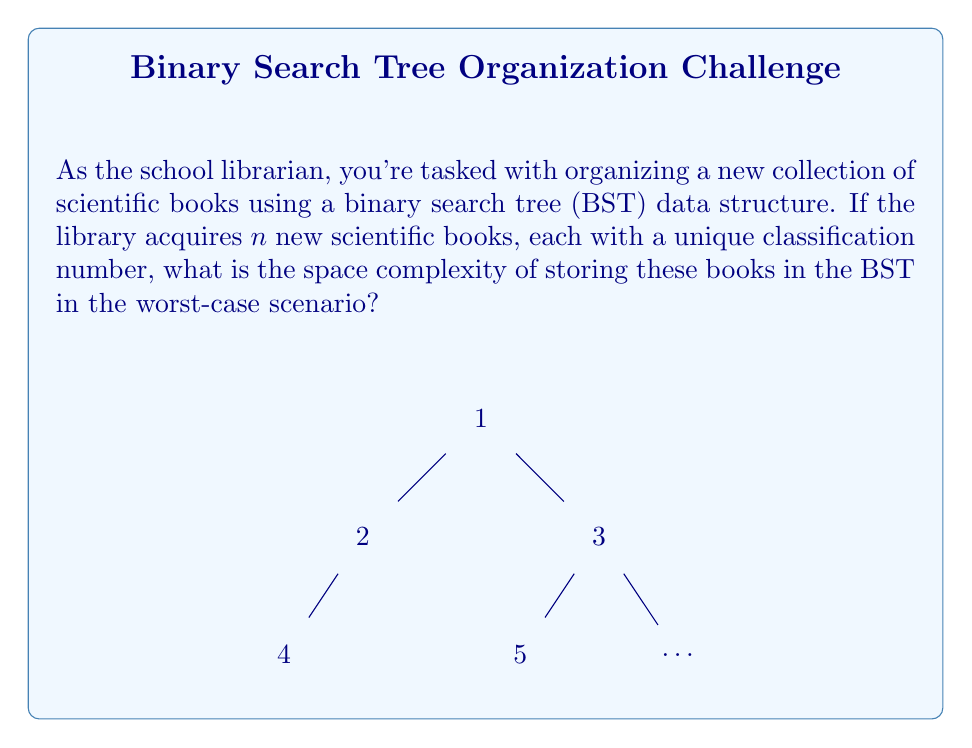Show me your answer to this math problem. To determine the space complexity, let's consider the structure of a binary search tree:

1) Each node in the BST represents a book and contains:
   - The book's classification number
   - Two pointers (left and right child)

2) In the worst-case scenario, the BST becomes a linear chain (essentially a linked list). This happens when books are added in sorted order.

3) For each node, we need to store:
   - The classification number: typically an integer, which takes $O(1)$ space
   - Two pointers: each pointer takes $O(1)$ space

4) So, each node requires $O(1)$ space.

5) In the worst case, we have $n$ nodes (one for each book).

6) Therefore, the total space required is:

   $$O(1) \times n = O(n)$$

This linear space complexity holds true regardless of whether the tree is balanced or not. Even in the best-case scenario (a perfectly balanced tree), we still need to store all $n$ nodes, each taking constant space.

It's worth noting that while the space complexity remains $O(n)$, a balanced tree would provide better time complexity for operations like search and insert ($O(\log n)$ instead of $O(n)$ in the worst case).
Answer: $O(n)$ 